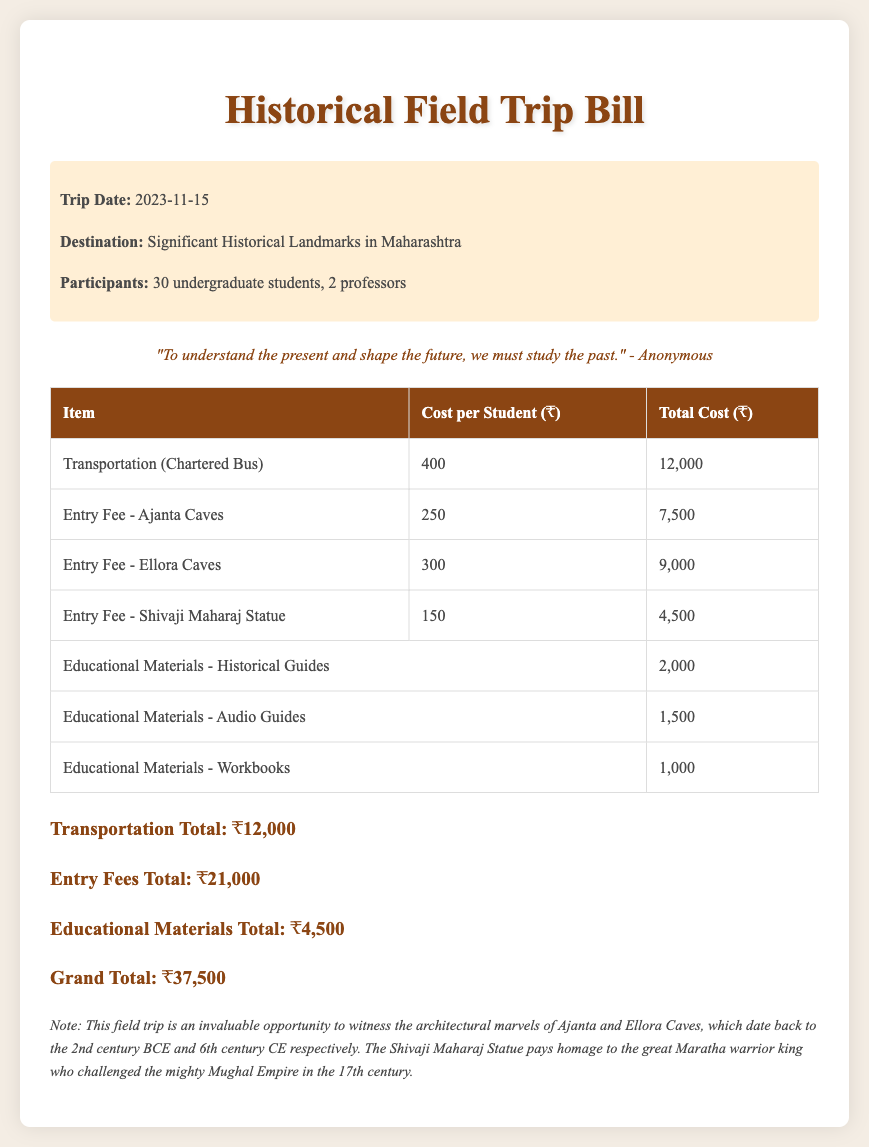What is the trip date? The trip date is specifically mentioned in the document, highlighting when the field trip will take place.
Answer: 2023-11-15 What is the total cost for transportation? The total cost for transportation is calculated from the cost per student and the number of students participating.
Answer: ₹12,000 How many participants are there? The document clearly states the number of undergraduate students and professors participating in the trip.
Answer: 30 undergraduate students, 2 professors What is the entry fee for Ajanta Caves? This specific fee is listed in the table detailing the costs for entry to various landmarks visited during the trip.
Answer: ₹250 What is the grand total of the trip? The grand total is the sum of all individual costs outlined in the document, representing the total expenditure for the field trip.
Answer: ₹37,500 How much are the educational materials for historical guides? The document provides a breakdown of costs for different types of educational materials, including historical guides.
Answer: ₹2,000 What percentage of the grand total is from entry fees? The reasoning of this question involves calculating entry fees as a portion of the grand total presented in the document.
Answer: 56% What is included in the educational materials? The document specifies several types of educational materials that are part of the overall costs, indicating what students will receive.
Answer: Historical Guides, Audio Guides, Workbooks What is the significance of the Shivaji Maharaj Statue mentioned in the document? The footnote provides historical context about the statue, explaining its relevance.
Answer: Honoring the Maratha warrior king 